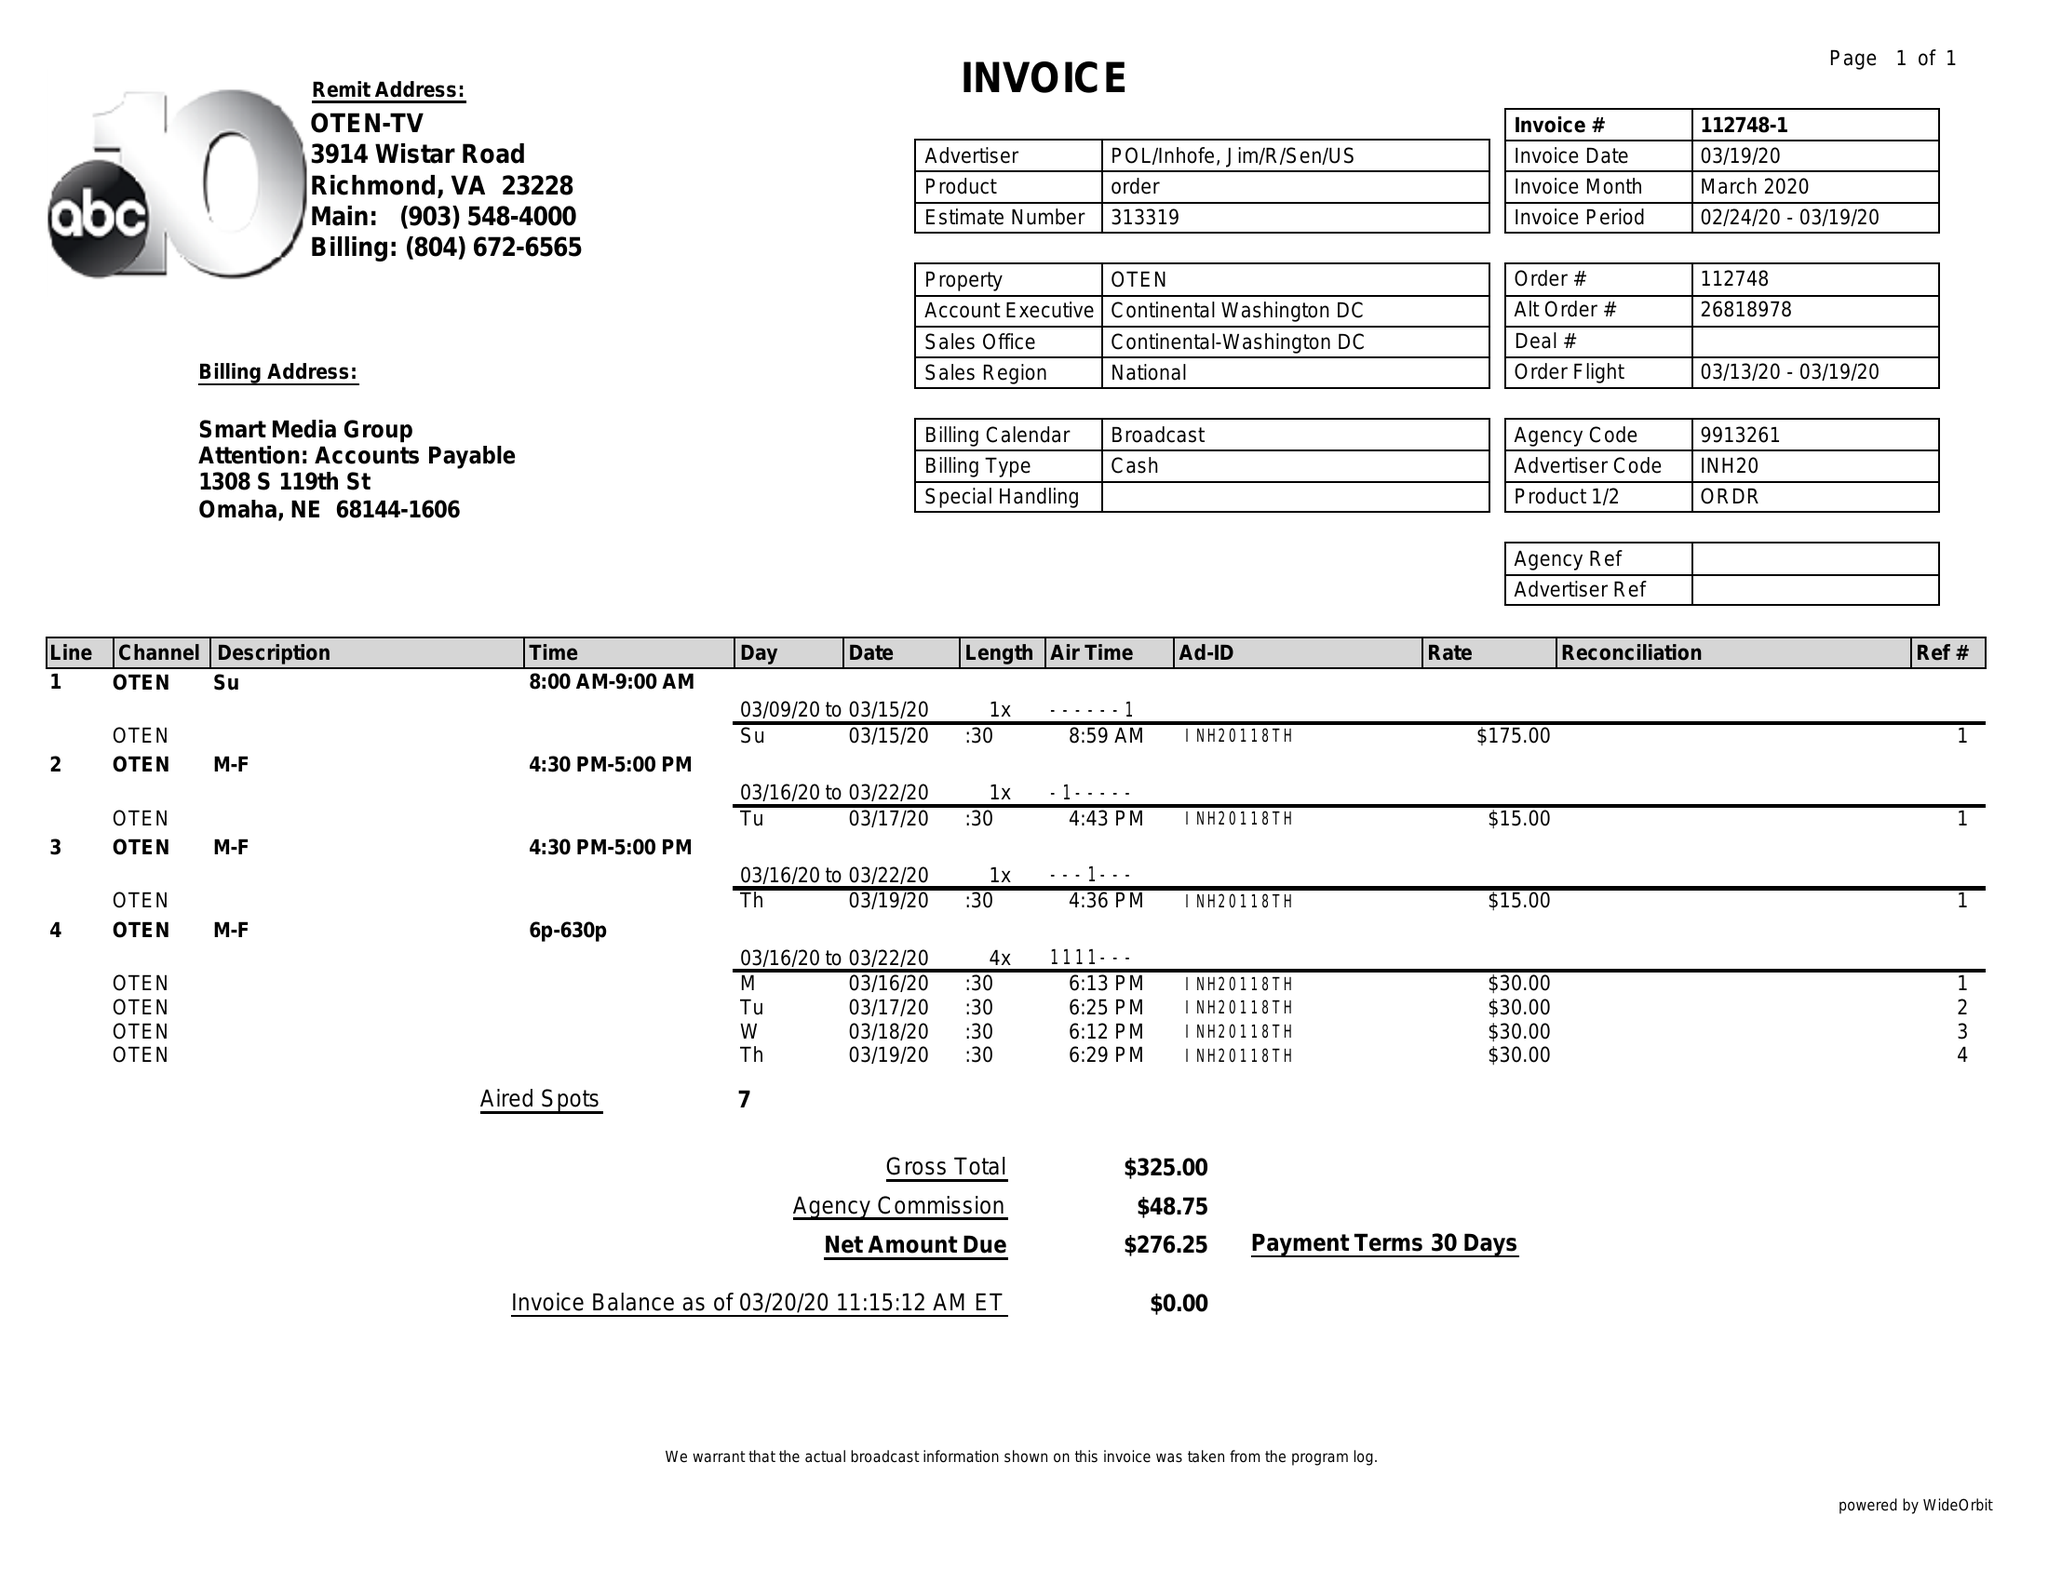What is the value for the contract_num?
Answer the question using a single word or phrase. 112748 